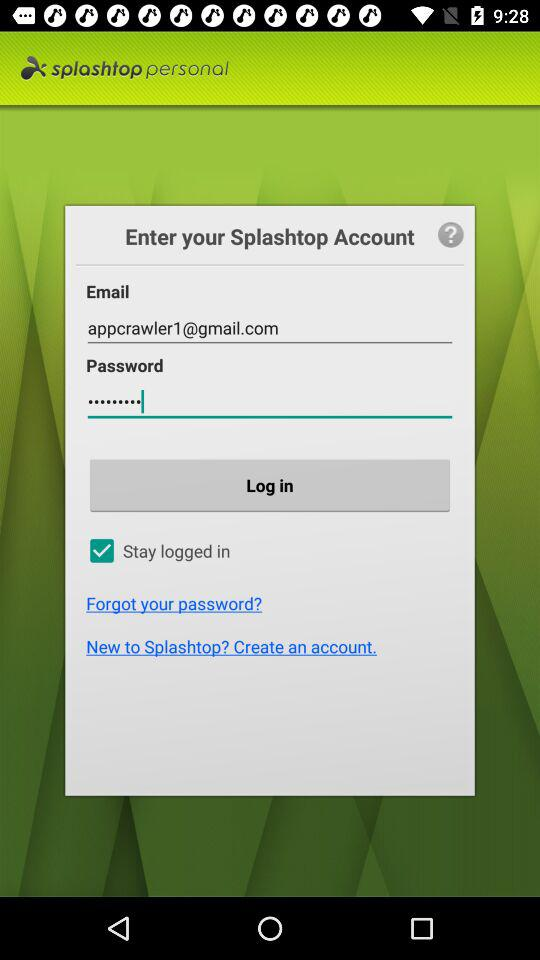How many fields are there for entering login information?
Answer the question using a single word or phrase. 2 